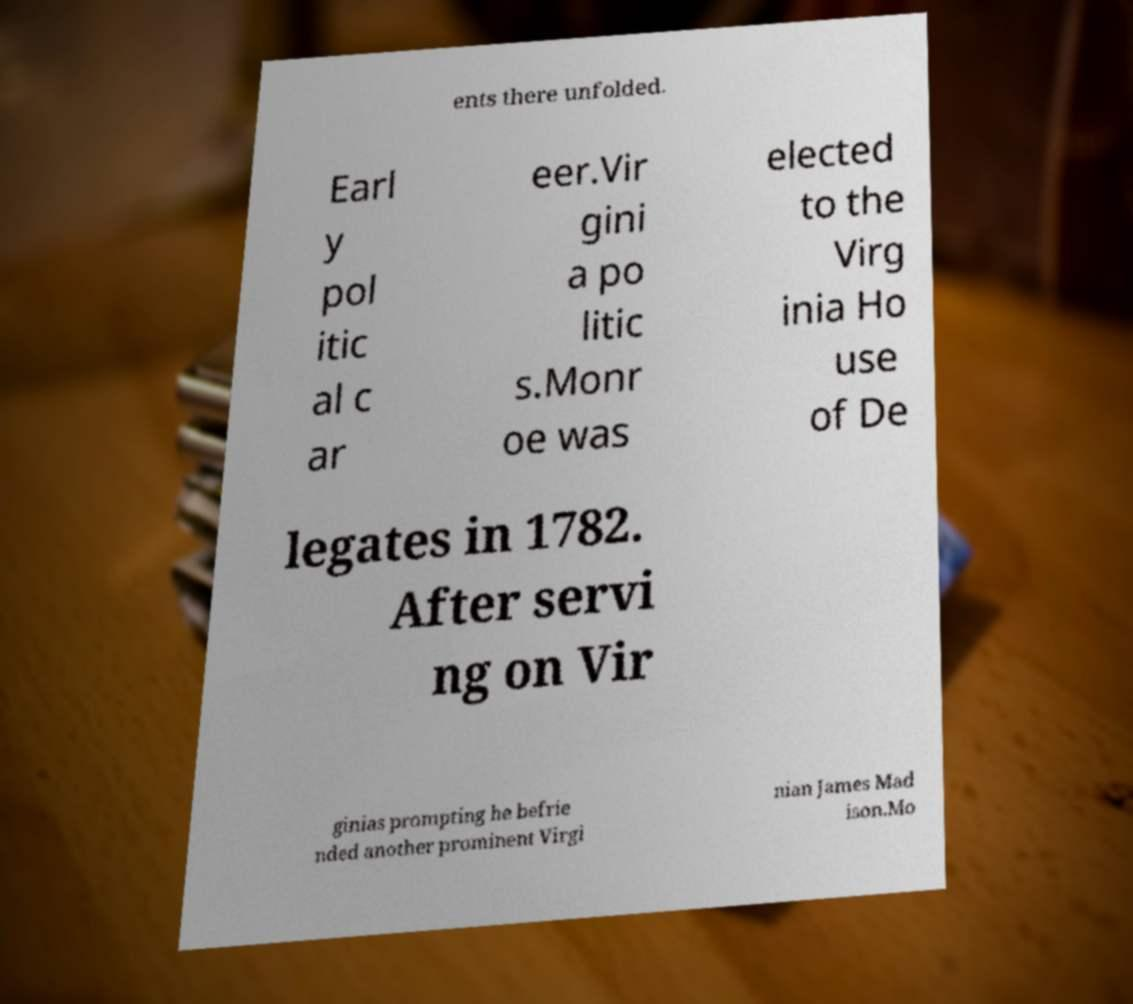For documentation purposes, I need the text within this image transcribed. Could you provide that? ents there unfolded. Earl y pol itic al c ar eer.Vir gini a po litic s.Monr oe was elected to the Virg inia Ho use of De legates in 1782. After servi ng on Vir ginias prompting he befrie nded another prominent Virgi nian James Mad ison.Mo 